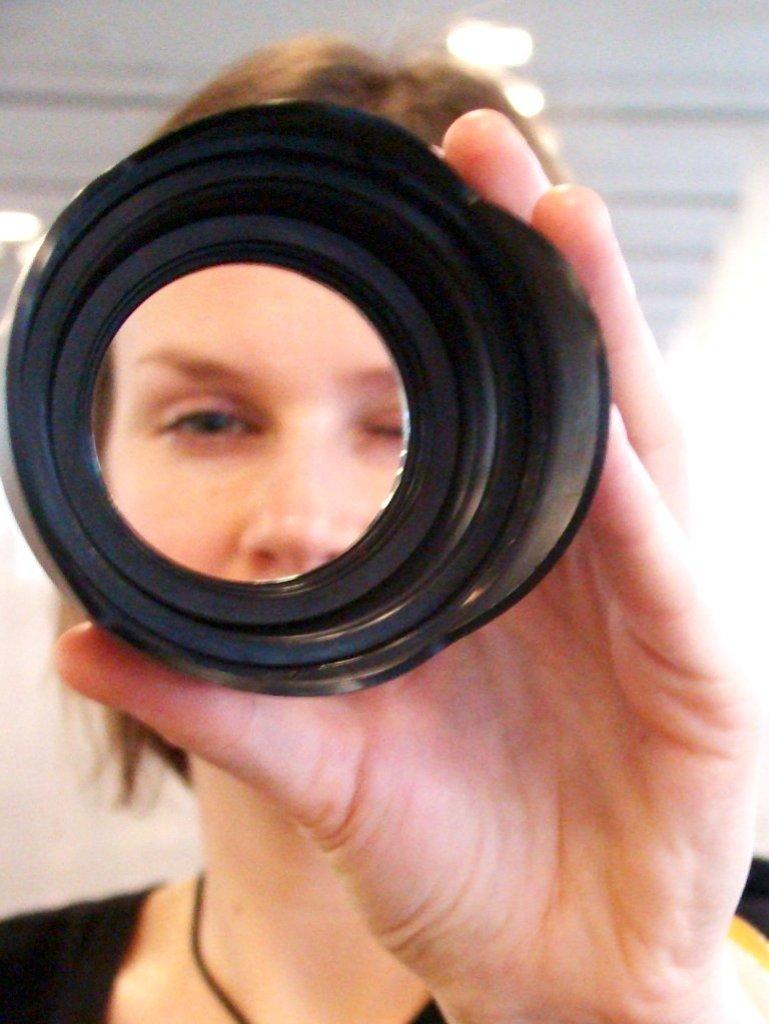What is the main subject of the image? The main subject of the image is a lady. What is the lady holding in the image? The lady is holding a black color object. Can you describe the background of the image? The background of the image is blurred. How many snakes can be seen slithering in the image? There are no snakes present in the image. What type of motion is the lady performing in the image? The image does not depict any motion or action being performed by the lady. 